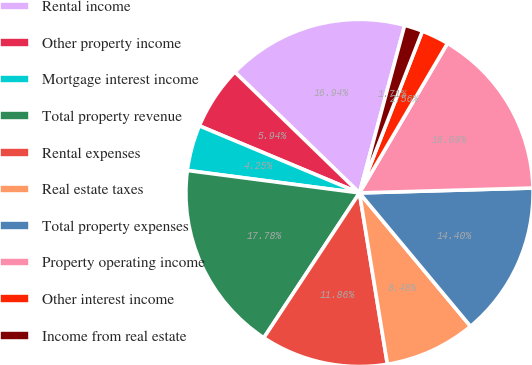Convert chart to OTSL. <chart><loc_0><loc_0><loc_500><loc_500><pie_chart><fcel>Rental income<fcel>Other property income<fcel>Mortgage interest income<fcel>Total property revenue<fcel>Rental expenses<fcel>Real estate taxes<fcel>Total property expenses<fcel>Property operating income<fcel>Other interest income<fcel>Income from real estate<nl><fcel>16.94%<fcel>5.94%<fcel>4.25%<fcel>17.78%<fcel>11.86%<fcel>8.48%<fcel>14.4%<fcel>16.09%<fcel>2.56%<fcel>1.71%<nl></chart> 